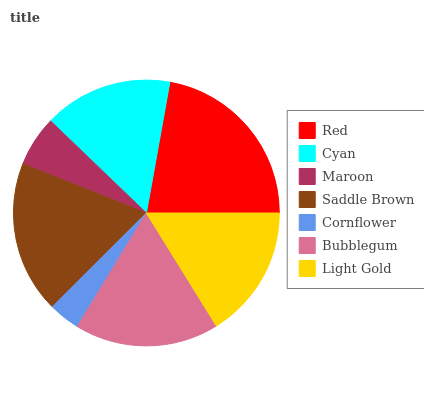Is Cornflower the minimum?
Answer yes or no. Yes. Is Red the maximum?
Answer yes or no. Yes. Is Cyan the minimum?
Answer yes or no. No. Is Cyan the maximum?
Answer yes or no. No. Is Red greater than Cyan?
Answer yes or no. Yes. Is Cyan less than Red?
Answer yes or no. Yes. Is Cyan greater than Red?
Answer yes or no. No. Is Red less than Cyan?
Answer yes or no. No. Is Light Gold the high median?
Answer yes or no. Yes. Is Light Gold the low median?
Answer yes or no. Yes. Is Maroon the high median?
Answer yes or no. No. Is Cyan the low median?
Answer yes or no. No. 